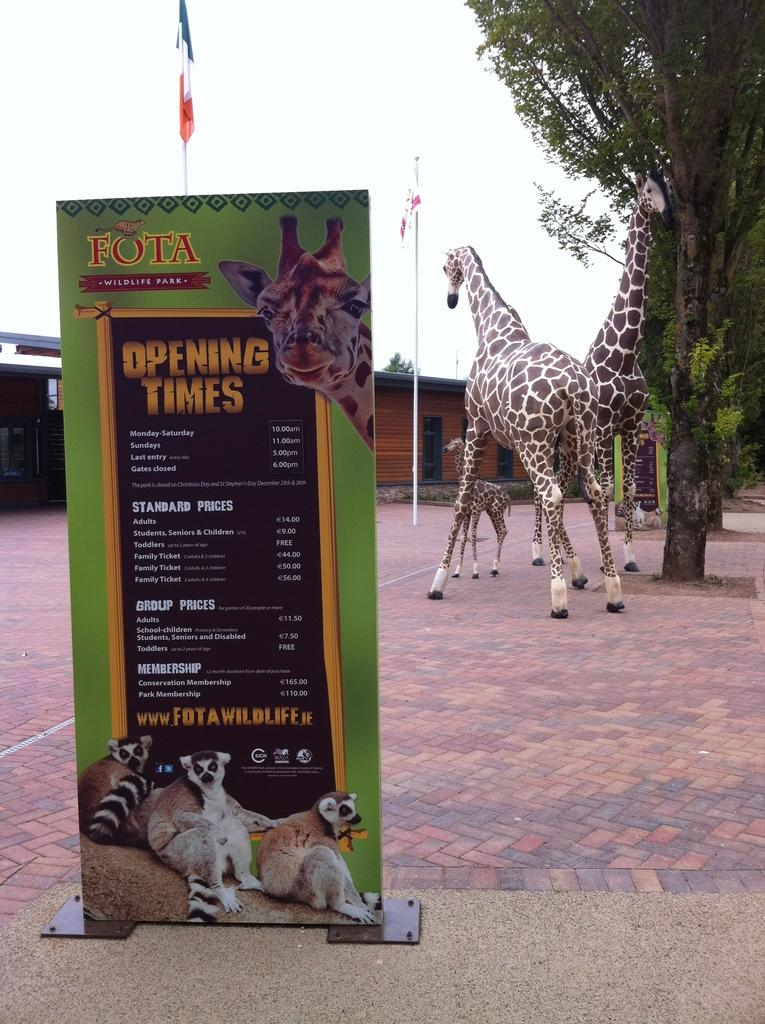What type of animals can be seen in the image? There are giraffes in the image. What other objects or features can be seen in the image? There are trees, sheds, flags, and a board with text and logos in the image. What is depicted on the board in the image? There are pictures of animals on the board. How many sacks are being carried by the giraffes in the image? There are no sacks present in the image; the giraffes are not carrying anything. What is the elbow of the giraffe used for in the image? Giraffes do not have elbows, as they are mammals with long necks and legs. 